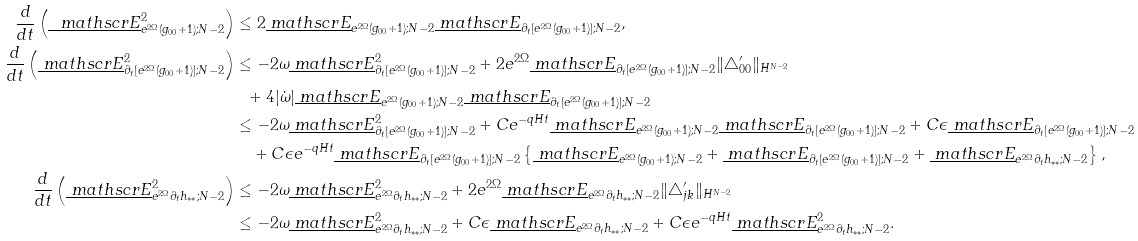<formula> <loc_0><loc_0><loc_500><loc_500>\frac { d } { d t } \left ( \underline { \ m a t h s c r { E } } _ { e ^ { 2 \Omega } ( g _ { 0 0 } + 1 ) ; N - 2 } ^ { 2 } \right ) & \leq 2 \underline { \ m a t h s c r { E } } _ { e ^ { 2 \Omega } ( g _ { 0 0 } + 1 ) ; N - 2 } \underline { \ m a t h s c r { E } } _ { \partial _ { t } [ e ^ { 2 \Omega } ( g _ { 0 0 } + 1 ) ] ; N - 2 } , \\ \frac { d } { d t } \left ( \underline { \ m a t h s c r { E } } _ { \partial _ { t } [ e ^ { 2 \Omega } ( g _ { 0 0 } + 1 ) ] ; N - 2 } ^ { 2 } \right ) & \leq - 2 \omega \underline { \ m a t h s c r { E } } _ { \partial _ { t } [ e ^ { 2 \Omega } ( g _ { 0 0 } + 1 ) ] ; N - 2 } ^ { 2 } + 2 e ^ { 2 \Omega } \underline { \ m a t h s c r { E } } _ { \partial _ { t } [ e ^ { 2 \Omega } ( g _ { 0 0 } + 1 ) ] ; N - 2 } \| \triangle ^ { \prime } _ { 0 0 } \| _ { H ^ { N - 2 } } \\ & \ \ + 4 | \dot { \omega } | \underline { \ m a t h s c r { E } } _ { e ^ { 2 \Omega } ( g _ { 0 0 } + 1 ) ; N - 2 } \underline { \ m a t h s c r { E } } _ { \partial _ { t } [ e ^ { 2 \Omega } ( g _ { 0 0 } + 1 ) ] ; N - 2 } \\ & \leq - 2 \omega \underline { \ m a t h s c r { E } } _ { \partial _ { t } [ e ^ { 2 \Omega } ( g _ { 0 0 } + 1 ) ] ; N - 2 } ^ { 2 } + C e ^ { - q H t } \underline { \ m a t h s c r { E } } _ { e ^ { 2 \Omega } ( g _ { 0 0 } + 1 ) ; N - 2 } \underline { \ m a t h s c r { E } } _ { \partial _ { t } [ e ^ { 2 \Omega } ( g _ { 0 0 } + 1 ) ] ; N - 2 } + C \epsilon \underline { \ m a t h s c r { E } } _ { \partial _ { t } [ e ^ { 2 \Omega } ( g _ { 0 0 } + 1 ) ] ; N - 2 } \\ & \quad + C \epsilon e ^ { - q H t } \underline { \ m a t h s c r { E } } _ { \partial _ { t } [ e ^ { 2 \Omega } ( g _ { 0 0 } + 1 ) ] ; N - 2 } \left \{ \underline { \ m a t h s c r { E } } _ { e ^ { 2 \Omega } ( g _ { 0 0 } + 1 ) ; N - 2 } + \underline { \ m a t h s c r { E } } _ { \partial _ { t } [ e ^ { 2 \Omega } ( g _ { 0 0 } + 1 ) ] ; N - 2 } + \underline { \ m a t h s c r { E } } _ { e ^ { 2 \Omega } \partial _ { t } h _ { * * } ; N - 2 } \right \} , \\ \frac { d } { d t } \left ( \underline { \ m a t h s c r { E } } _ { e ^ { 2 \Omega } \partial _ { t } h _ { * * } ; N - 2 } ^ { 2 } \right ) & \leq - 2 \omega \underline { \ m a t h s c r { E } } _ { e ^ { 2 \Omega } \partial _ { t } h _ { * * } ; N - 2 } ^ { 2 } + 2 e ^ { 2 \Omega } \underline { \ m a t h s c r { E } } _ { e ^ { 2 \Omega } \partial _ { t } h _ { * * } ; N - 2 } \| \triangle ^ { \prime } _ { j k } \| _ { H ^ { N - 2 } } \\ & \leq - 2 \omega \underline { \ m a t h s c r { E } } _ { e ^ { 2 \Omega } \partial _ { t } h _ { * * } ; N - 2 } ^ { 2 } + C \epsilon \underline { \ m a t h s c r { E } } _ { e ^ { 2 \Omega } \partial _ { t } h _ { * * } ; N - 2 } + C \epsilon e ^ { - q H t } \underline { \ m a t h s c r { E } } _ { e ^ { 2 \Omega } \partial _ { t } h _ { * * } ; N - 2 } ^ { 2 } .</formula> 